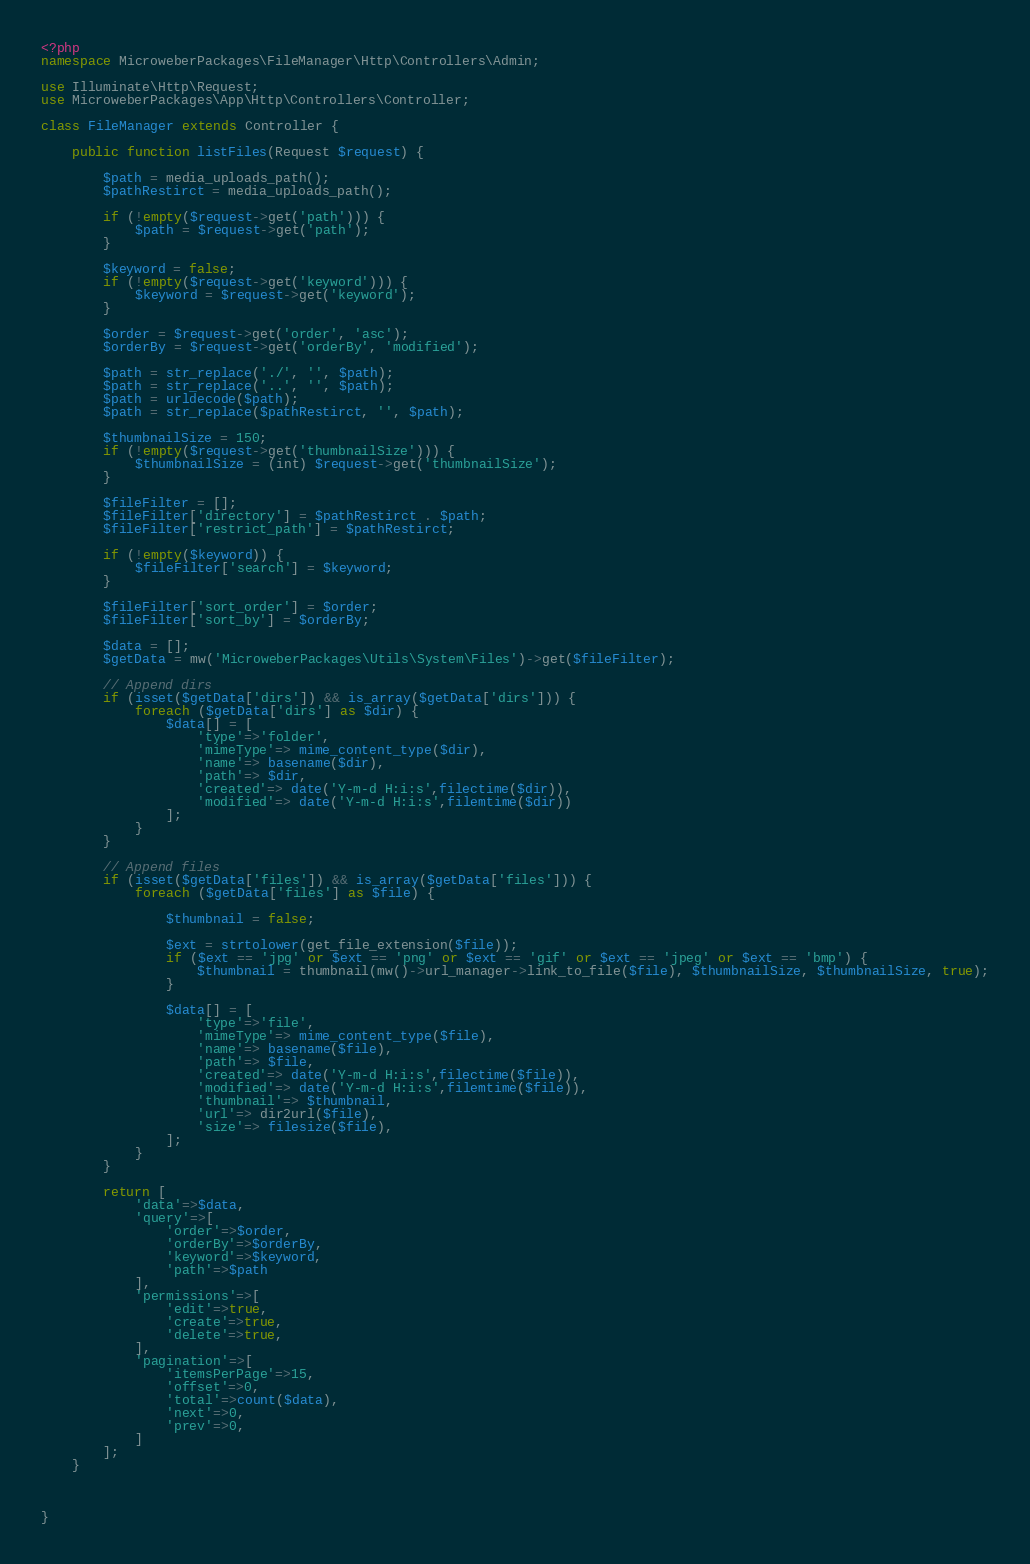Convert code to text. <code><loc_0><loc_0><loc_500><loc_500><_PHP_><?php
namespace MicroweberPackages\FileManager\Http\Controllers\Admin;

use Illuminate\Http\Request;
use MicroweberPackages\App\Http\Controllers\Controller;

class FileManager extends Controller {

    public function listFiles(Request $request) {

        $path = media_uploads_path();
        $pathRestirct = media_uploads_path();

        if (!empty($request->get('path'))) {
            $path = $request->get('path');
        }

        $keyword = false;
        if (!empty($request->get('keyword'))) {
            $keyword = $request->get('keyword');
        }

        $order = $request->get('order', 'asc');
        $orderBy = $request->get('orderBy', 'modified');

        $path = str_replace('./', '', $path);
        $path = str_replace('..', '', $path);
        $path = urldecode($path);
        $path = str_replace($pathRestirct, '', $path);

        $thumbnailSize = 150;
        if (!empty($request->get('thumbnailSize'))) {
            $thumbnailSize = (int) $request->get('thumbnailSize');
        }

        $fileFilter = [];
        $fileFilter['directory'] = $pathRestirct . $path;
        $fileFilter['restrict_path'] = $pathRestirct;

        if (!empty($keyword)) {
            $fileFilter['search'] = $keyword;
        }

        $fileFilter['sort_order'] = $order;
        $fileFilter['sort_by'] = $orderBy;

        $data = [];
        $getData = mw('MicroweberPackages\Utils\System\Files')->get($fileFilter);

        // Append dirs
        if (isset($getData['dirs']) && is_array($getData['dirs'])) {
            foreach ($getData['dirs'] as $dir) {
                $data[] = [
                    'type'=>'folder',
                    'mimeType'=> mime_content_type($dir),
                    'name'=> basename($dir),
                    'path'=> $dir,
                    'created'=> date('Y-m-d H:i:s',filectime($dir)),
                    'modified'=> date('Y-m-d H:i:s',filemtime($dir))
                ];
            }
        }

        // Append files
        if (isset($getData['files']) && is_array($getData['files'])) {
            foreach ($getData['files'] as $file) {

                $thumbnail = false;

                $ext = strtolower(get_file_extension($file));
                if ($ext == 'jpg' or $ext == 'png' or $ext == 'gif' or $ext == 'jpeg' or $ext == 'bmp') {
                    $thumbnail = thumbnail(mw()->url_manager->link_to_file($file), $thumbnailSize, $thumbnailSize, true);
                }

                $data[] = [
                    'type'=>'file',
                    'mimeType'=> mime_content_type($file),
                    'name'=> basename($file),
                    'path'=> $file,
                    'created'=> date('Y-m-d H:i:s',filectime($file)),
                    'modified'=> date('Y-m-d H:i:s',filemtime($file)),
                    'thumbnail'=> $thumbnail,
                    'url'=> dir2url($file),
                    'size'=> filesize($file),
                ];
            }
        }

        return [
            'data'=>$data,
            'query'=>[
                'order'=>$order,
                'orderBy'=>$orderBy,
                'keyword'=>$keyword,
                'path'=>$path
            ],
            'permissions'=>[
                'edit'=>true,
                'create'=>true,
                'delete'=>true,
            ],
            'pagination'=>[
                'itemsPerPage'=>15,
                'offset'=>0,
                'total'=>count($data),
                'next'=>0,
                'prev'=>0,
            ]
        ];
    }



}</code> 